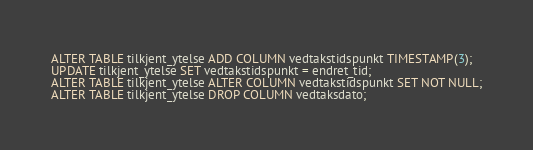<code> <loc_0><loc_0><loc_500><loc_500><_SQL_>ALTER TABLE tilkjent_ytelse ADD COLUMN vedtakstidspunkt TIMESTAMP(3);
UPDATE tilkjent_ytelse SET vedtakstidspunkt = endret_tid;
ALTER TABLE tilkjent_ytelse ALTER COLUMN vedtakstidspunkt SET NOT NULL;
ALTER TABLE tilkjent_ytelse DROP COLUMN vedtaksdato;</code> 